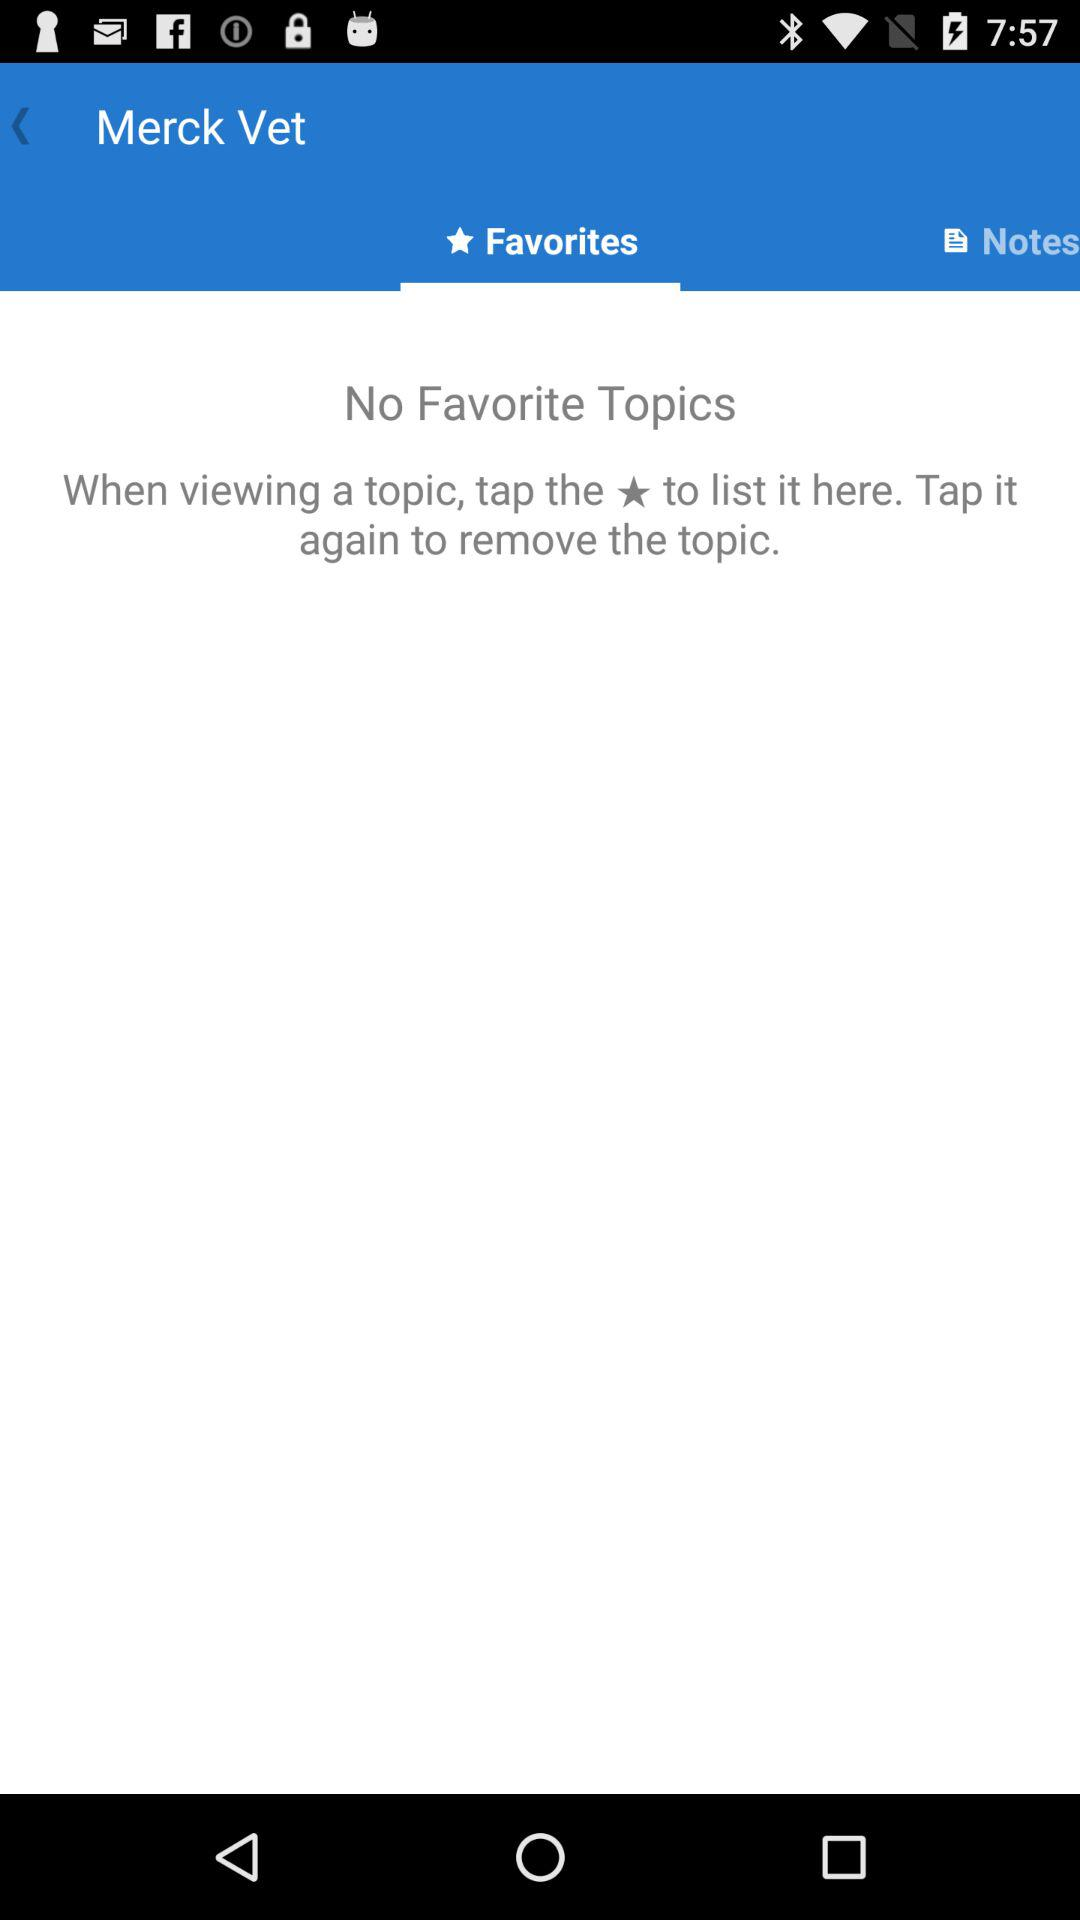How many topics in total can be listed here?
When the provided information is insufficient, respond with <no answer>. <no answer> 